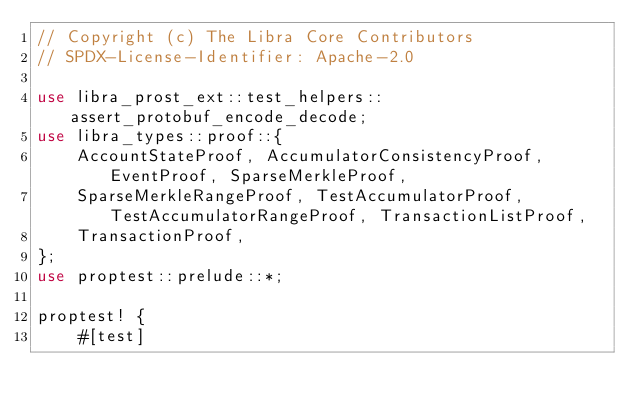Convert code to text. <code><loc_0><loc_0><loc_500><loc_500><_Rust_>// Copyright (c) The Libra Core Contributors
// SPDX-License-Identifier: Apache-2.0

use libra_prost_ext::test_helpers::assert_protobuf_encode_decode;
use libra_types::proof::{
    AccountStateProof, AccumulatorConsistencyProof, EventProof, SparseMerkleProof,
    SparseMerkleRangeProof, TestAccumulatorProof, TestAccumulatorRangeProof, TransactionListProof,
    TransactionProof,
};
use proptest::prelude::*;

proptest! {
    #[test]</code> 